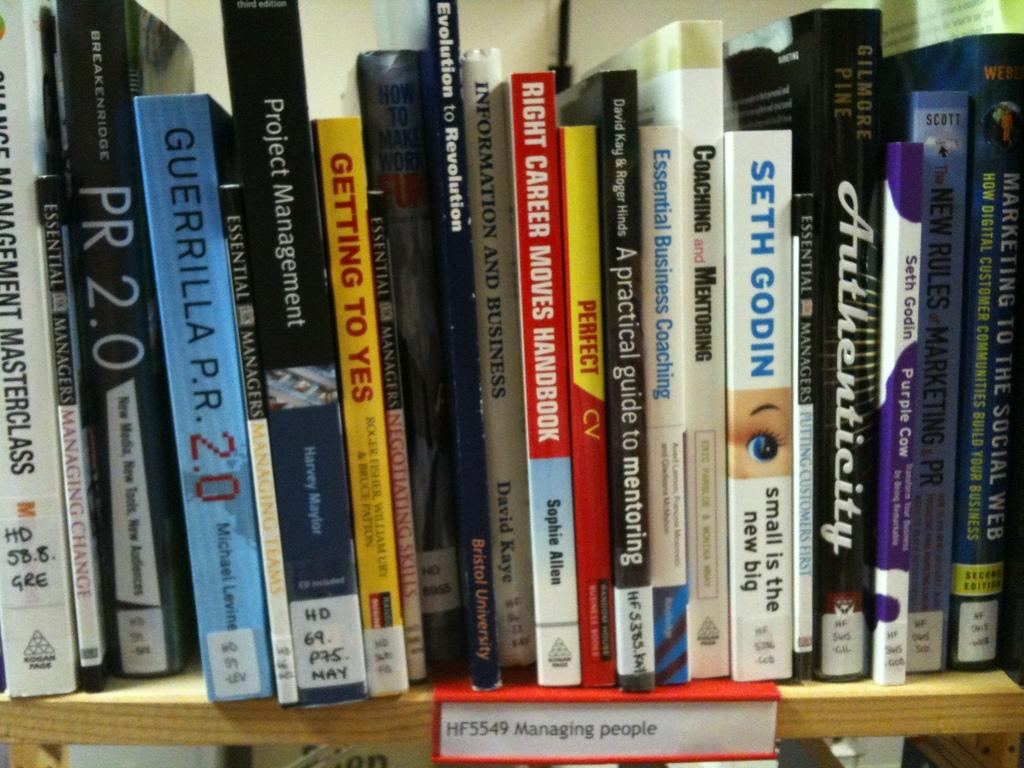<image>
Write a terse but informative summary of the picture. Books are lined up on a shelf with the tag Managing people below them. 